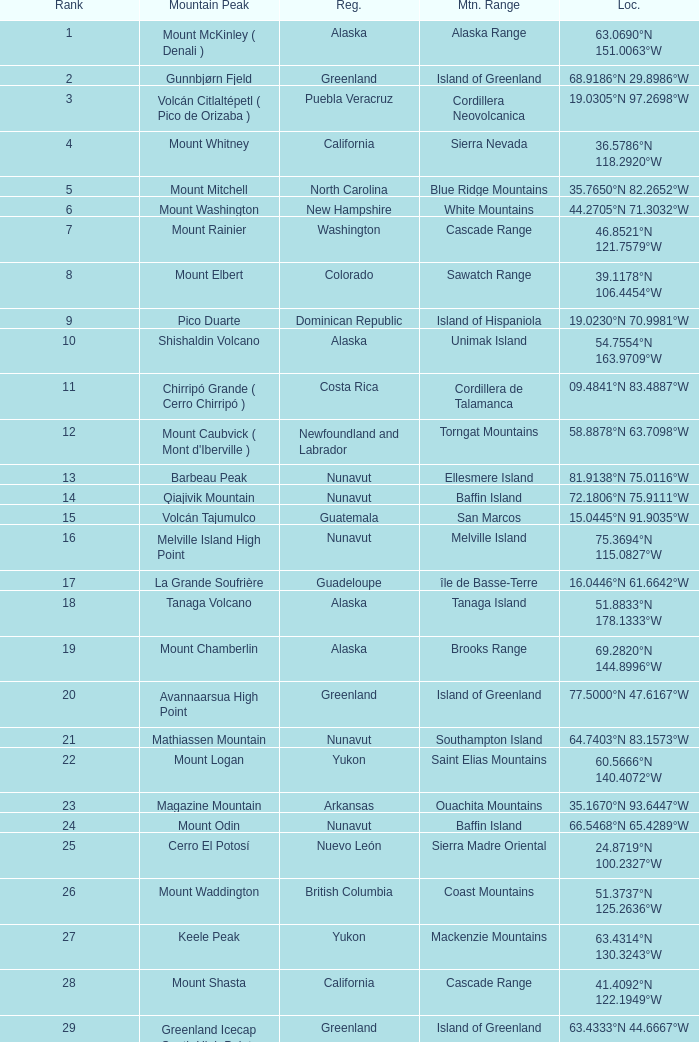Which Mountain Peak has a Region of baja california, and a Location of 28.1301°n 115.2206°w? Isla Cedros High Point. 